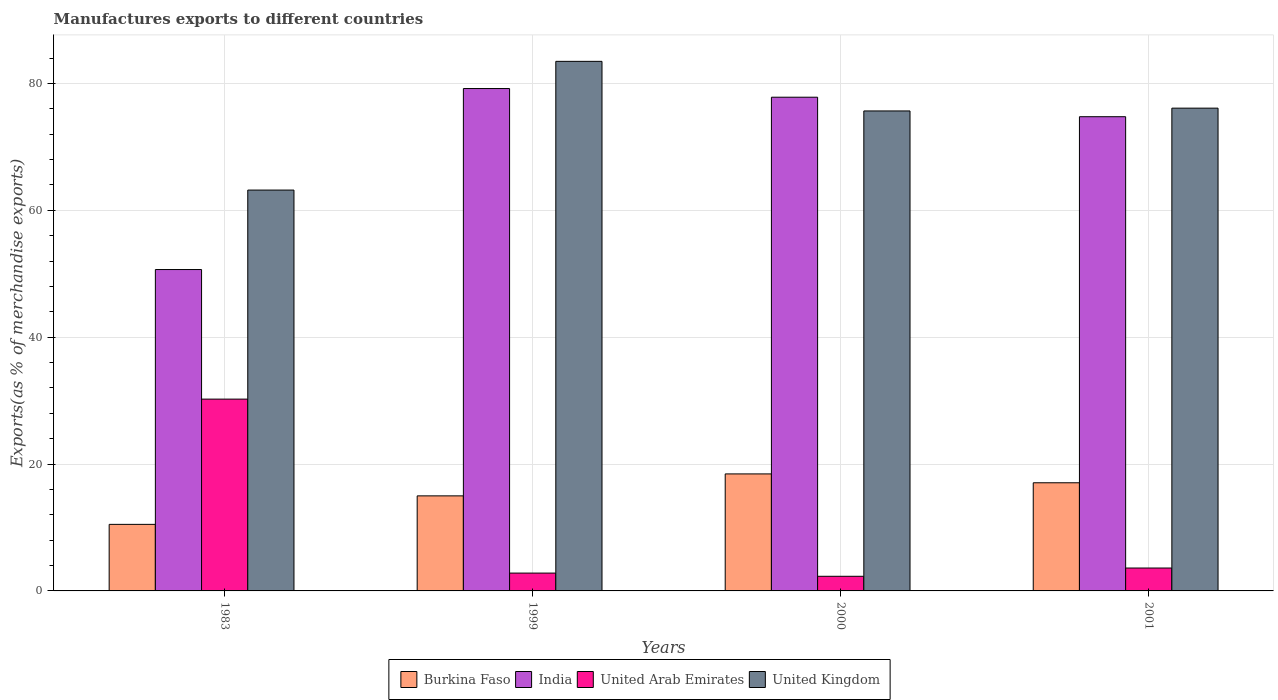How many different coloured bars are there?
Your response must be concise. 4. Are the number of bars on each tick of the X-axis equal?
Keep it short and to the point. Yes. How many bars are there on the 4th tick from the right?
Offer a terse response. 4. What is the label of the 1st group of bars from the left?
Offer a very short reply. 1983. What is the percentage of exports to different countries in India in 2001?
Provide a short and direct response. 74.76. Across all years, what is the maximum percentage of exports to different countries in Burkina Faso?
Your answer should be very brief. 18.45. Across all years, what is the minimum percentage of exports to different countries in India?
Provide a succinct answer. 50.67. In which year was the percentage of exports to different countries in United Kingdom maximum?
Provide a succinct answer. 1999. In which year was the percentage of exports to different countries in United Kingdom minimum?
Provide a succinct answer. 1983. What is the total percentage of exports to different countries in Burkina Faso in the graph?
Offer a terse response. 60.98. What is the difference between the percentage of exports to different countries in United Arab Emirates in 1999 and that in 2000?
Keep it short and to the point. 0.51. What is the difference between the percentage of exports to different countries in India in 2001 and the percentage of exports to different countries in United Arab Emirates in 1999?
Offer a terse response. 71.95. What is the average percentage of exports to different countries in Burkina Faso per year?
Make the answer very short. 15.24. In the year 1999, what is the difference between the percentage of exports to different countries in United Arab Emirates and percentage of exports to different countries in India?
Ensure brevity in your answer.  -76.39. In how many years, is the percentage of exports to different countries in India greater than 8 %?
Provide a short and direct response. 4. What is the ratio of the percentage of exports to different countries in India in 1983 to that in 2001?
Ensure brevity in your answer.  0.68. Is the percentage of exports to different countries in United Kingdom in 1999 less than that in 2001?
Offer a terse response. No. Is the difference between the percentage of exports to different countries in United Arab Emirates in 1983 and 2001 greater than the difference between the percentage of exports to different countries in India in 1983 and 2001?
Make the answer very short. Yes. What is the difference between the highest and the second highest percentage of exports to different countries in United Arab Emirates?
Offer a terse response. 26.63. What is the difference between the highest and the lowest percentage of exports to different countries in United Arab Emirates?
Your answer should be very brief. 27.93. Is it the case that in every year, the sum of the percentage of exports to different countries in India and percentage of exports to different countries in United Arab Emirates is greater than the sum of percentage of exports to different countries in United Kingdom and percentage of exports to different countries in Burkina Faso?
Offer a terse response. No. Is it the case that in every year, the sum of the percentage of exports to different countries in Burkina Faso and percentage of exports to different countries in United Kingdom is greater than the percentage of exports to different countries in India?
Give a very brief answer. Yes. How many bars are there?
Provide a short and direct response. 16. Are all the bars in the graph horizontal?
Provide a short and direct response. No. How many years are there in the graph?
Your response must be concise. 4. Does the graph contain any zero values?
Your response must be concise. No. Does the graph contain grids?
Keep it short and to the point. Yes. How many legend labels are there?
Offer a very short reply. 4. How are the legend labels stacked?
Provide a short and direct response. Horizontal. What is the title of the graph?
Your response must be concise. Manufactures exports to different countries. Does "Turks and Caicos Islands" appear as one of the legend labels in the graph?
Your response must be concise. No. What is the label or title of the Y-axis?
Offer a terse response. Exports(as % of merchandise exports). What is the Exports(as % of merchandise exports) of Burkina Faso in 1983?
Give a very brief answer. 10.49. What is the Exports(as % of merchandise exports) of India in 1983?
Your answer should be very brief. 50.67. What is the Exports(as % of merchandise exports) in United Arab Emirates in 1983?
Your response must be concise. 30.24. What is the Exports(as % of merchandise exports) in United Kingdom in 1983?
Make the answer very short. 63.2. What is the Exports(as % of merchandise exports) of Burkina Faso in 1999?
Keep it short and to the point. 14.98. What is the Exports(as % of merchandise exports) in India in 1999?
Ensure brevity in your answer.  79.2. What is the Exports(as % of merchandise exports) of United Arab Emirates in 1999?
Provide a short and direct response. 2.81. What is the Exports(as % of merchandise exports) in United Kingdom in 1999?
Your response must be concise. 83.49. What is the Exports(as % of merchandise exports) of Burkina Faso in 2000?
Give a very brief answer. 18.45. What is the Exports(as % of merchandise exports) of India in 2000?
Your answer should be compact. 77.84. What is the Exports(as % of merchandise exports) of United Arab Emirates in 2000?
Provide a short and direct response. 2.31. What is the Exports(as % of merchandise exports) in United Kingdom in 2000?
Your answer should be compact. 75.67. What is the Exports(as % of merchandise exports) in Burkina Faso in 2001?
Ensure brevity in your answer.  17.05. What is the Exports(as % of merchandise exports) of India in 2001?
Ensure brevity in your answer.  74.76. What is the Exports(as % of merchandise exports) of United Arab Emirates in 2001?
Keep it short and to the point. 3.61. What is the Exports(as % of merchandise exports) in United Kingdom in 2001?
Provide a succinct answer. 76.11. Across all years, what is the maximum Exports(as % of merchandise exports) of Burkina Faso?
Your answer should be very brief. 18.45. Across all years, what is the maximum Exports(as % of merchandise exports) of India?
Keep it short and to the point. 79.2. Across all years, what is the maximum Exports(as % of merchandise exports) in United Arab Emirates?
Ensure brevity in your answer.  30.24. Across all years, what is the maximum Exports(as % of merchandise exports) of United Kingdom?
Your response must be concise. 83.49. Across all years, what is the minimum Exports(as % of merchandise exports) of Burkina Faso?
Provide a succinct answer. 10.49. Across all years, what is the minimum Exports(as % of merchandise exports) in India?
Keep it short and to the point. 50.67. Across all years, what is the minimum Exports(as % of merchandise exports) of United Arab Emirates?
Provide a succinct answer. 2.31. Across all years, what is the minimum Exports(as % of merchandise exports) in United Kingdom?
Provide a succinct answer. 63.2. What is the total Exports(as % of merchandise exports) of Burkina Faso in the graph?
Offer a very short reply. 60.98. What is the total Exports(as % of merchandise exports) of India in the graph?
Make the answer very short. 282.47. What is the total Exports(as % of merchandise exports) in United Arab Emirates in the graph?
Your answer should be compact. 38.97. What is the total Exports(as % of merchandise exports) of United Kingdom in the graph?
Provide a short and direct response. 298.47. What is the difference between the Exports(as % of merchandise exports) in Burkina Faso in 1983 and that in 1999?
Provide a short and direct response. -4.49. What is the difference between the Exports(as % of merchandise exports) in India in 1983 and that in 1999?
Keep it short and to the point. -28.53. What is the difference between the Exports(as % of merchandise exports) in United Arab Emirates in 1983 and that in 1999?
Offer a terse response. 27.43. What is the difference between the Exports(as % of merchandise exports) of United Kingdom in 1983 and that in 1999?
Your answer should be very brief. -20.29. What is the difference between the Exports(as % of merchandise exports) of Burkina Faso in 1983 and that in 2000?
Your answer should be compact. -7.96. What is the difference between the Exports(as % of merchandise exports) in India in 1983 and that in 2000?
Your answer should be very brief. -27.17. What is the difference between the Exports(as % of merchandise exports) in United Arab Emirates in 1983 and that in 2000?
Your answer should be very brief. 27.93. What is the difference between the Exports(as % of merchandise exports) of United Kingdom in 1983 and that in 2000?
Ensure brevity in your answer.  -12.47. What is the difference between the Exports(as % of merchandise exports) of Burkina Faso in 1983 and that in 2001?
Make the answer very short. -6.56. What is the difference between the Exports(as % of merchandise exports) in India in 1983 and that in 2001?
Offer a terse response. -24.09. What is the difference between the Exports(as % of merchandise exports) in United Arab Emirates in 1983 and that in 2001?
Offer a terse response. 26.63. What is the difference between the Exports(as % of merchandise exports) in United Kingdom in 1983 and that in 2001?
Provide a succinct answer. -12.91. What is the difference between the Exports(as % of merchandise exports) in Burkina Faso in 1999 and that in 2000?
Offer a terse response. -3.46. What is the difference between the Exports(as % of merchandise exports) in India in 1999 and that in 2000?
Your response must be concise. 1.37. What is the difference between the Exports(as % of merchandise exports) in United Arab Emirates in 1999 and that in 2000?
Ensure brevity in your answer.  0.51. What is the difference between the Exports(as % of merchandise exports) in United Kingdom in 1999 and that in 2000?
Make the answer very short. 7.82. What is the difference between the Exports(as % of merchandise exports) in Burkina Faso in 1999 and that in 2001?
Your answer should be compact. -2.07. What is the difference between the Exports(as % of merchandise exports) of India in 1999 and that in 2001?
Your answer should be very brief. 4.44. What is the difference between the Exports(as % of merchandise exports) of United Arab Emirates in 1999 and that in 2001?
Offer a very short reply. -0.8. What is the difference between the Exports(as % of merchandise exports) of United Kingdom in 1999 and that in 2001?
Your answer should be compact. 7.38. What is the difference between the Exports(as % of merchandise exports) of Burkina Faso in 2000 and that in 2001?
Your answer should be compact. 1.4. What is the difference between the Exports(as % of merchandise exports) of India in 2000 and that in 2001?
Offer a very short reply. 3.08. What is the difference between the Exports(as % of merchandise exports) of United Arab Emirates in 2000 and that in 2001?
Provide a short and direct response. -1.3. What is the difference between the Exports(as % of merchandise exports) in United Kingdom in 2000 and that in 2001?
Make the answer very short. -0.44. What is the difference between the Exports(as % of merchandise exports) of Burkina Faso in 1983 and the Exports(as % of merchandise exports) of India in 1999?
Offer a very short reply. -68.71. What is the difference between the Exports(as % of merchandise exports) in Burkina Faso in 1983 and the Exports(as % of merchandise exports) in United Arab Emirates in 1999?
Your answer should be compact. 7.68. What is the difference between the Exports(as % of merchandise exports) in Burkina Faso in 1983 and the Exports(as % of merchandise exports) in United Kingdom in 1999?
Keep it short and to the point. -73. What is the difference between the Exports(as % of merchandise exports) in India in 1983 and the Exports(as % of merchandise exports) in United Arab Emirates in 1999?
Offer a terse response. 47.86. What is the difference between the Exports(as % of merchandise exports) of India in 1983 and the Exports(as % of merchandise exports) of United Kingdom in 1999?
Make the answer very short. -32.82. What is the difference between the Exports(as % of merchandise exports) of United Arab Emirates in 1983 and the Exports(as % of merchandise exports) of United Kingdom in 1999?
Provide a succinct answer. -53.25. What is the difference between the Exports(as % of merchandise exports) of Burkina Faso in 1983 and the Exports(as % of merchandise exports) of India in 2000?
Provide a succinct answer. -67.35. What is the difference between the Exports(as % of merchandise exports) in Burkina Faso in 1983 and the Exports(as % of merchandise exports) in United Arab Emirates in 2000?
Make the answer very short. 8.19. What is the difference between the Exports(as % of merchandise exports) in Burkina Faso in 1983 and the Exports(as % of merchandise exports) in United Kingdom in 2000?
Ensure brevity in your answer.  -65.18. What is the difference between the Exports(as % of merchandise exports) of India in 1983 and the Exports(as % of merchandise exports) of United Arab Emirates in 2000?
Offer a very short reply. 48.36. What is the difference between the Exports(as % of merchandise exports) in India in 1983 and the Exports(as % of merchandise exports) in United Kingdom in 2000?
Your answer should be very brief. -25. What is the difference between the Exports(as % of merchandise exports) of United Arab Emirates in 1983 and the Exports(as % of merchandise exports) of United Kingdom in 2000?
Ensure brevity in your answer.  -45.43. What is the difference between the Exports(as % of merchandise exports) in Burkina Faso in 1983 and the Exports(as % of merchandise exports) in India in 2001?
Make the answer very short. -64.27. What is the difference between the Exports(as % of merchandise exports) in Burkina Faso in 1983 and the Exports(as % of merchandise exports) in United Arab Emirates in 2001?
Offer a very short reply. 6.88. What is the difference between the Exports(as % of merchandise exports) of Burkina Faso in 1983 and the Exports(as % of merchandise exports) of United Kingdom in 2001?
Offer a very short reply. -65.62. What is the difference between the Exports(as % of merchandise exports) of India in 1983 and the Exports(as % of merchandise exports) of United Arab Emirates in 2001?
Your response must be concise. 47.06. What is the difference between the Exports(as % of merchandise exports) of India in 1983 and the Exports(as % of merchandise exports) of United Kingdom in 2001?
Offer a very short reply. -25.44. What is the difference between the Exports(as % of merchandise exports) in United Arab Emirates in 1983 and the Exports(as % of merchandise exports) in United Kingdom in 2001?
Provide a short and direct response. -45.87. What is the difference between the Exports(as % of merchandise exports) of Burkina Faso in 1999 and the Exports(as % of merchandise exports) of India in 2000?
Keep it short and to the point. -62.85. What is the difference between the Exports(as % of merchandise exports) of Burkina Faso in 1999 and the Exports(as % of merchandise exports) of United Arab Emirates in 2000?
Your answer should be compact. 12.68. What is the difference between the Exports(as % of merchandise exports) of Burkina Faso in 1999 and the Exports(as % of merchandise exports) of United Kingdom in 2000?
Keep it short and to the point. -60.69. What is the difference between the Exports(as % of merchandise exports) of India in 1999 and the Exports(as % of merchandise exports) of United Arab Emirates in 2000?
Provide a short and direct response. 76.9. What is the difference between the Exports(as % of merchandise exports) of India in 1999 and the Exports(as % of merchandise exports) of United Kingdom in 2000?
Ensure brevity in your answer.  3.53. What is the difference between the Exports(as % of merchandise exports) of United Arab Emirates in 1999 and the Exports(as % of merchandise exports) of United Kingdom in 2000?
Give a very brief answer. -72.86. What is the difference between the Exports(as % of merchandise exports) of Burkina Faso in 1999 and the Exports(as % of merchandise exports) of India in 2001?
Your answer should be very brief. -59.78. What is the difference between the Exports(as % of merchandise exports) of Burkina Faso in 1999 and the Exports(as % of merchandise exports) of United Arab Emirates in 2001?
Make the answer very short. 11.37. What is the difference between the Exports(as % of merchandise exports) in Burkina Faso in 1999 and the Exports(as % of merchandise exports) in United Kingdom in 2001?
Offer a very short reply. -61.13. What is the difference between the Exports(as % of merchandise exports) in India in 1999 and the Exports(as % of merchandise exports) in United Arab Emirates in 2001?
Give a very brief answer. 75.59. What is the difference between the Exports(as % of merchandise exports) in India in 1999 and the Exports(as % of merchandise exports) in United Kingdom in 2001?
Make the answer very short. 3.09. What is the difference between the Exports(as % of merchandise exports) of United Arab Emirates in 1999 and the Exports(as % of merchandise exports) of United Kingdom in 2001?
Your answer should be compact. -73.3. What is the difference between the Exports(as % of merchandise exports) in Burkina Faso in 2000 and the Exports(as % of merchandise exports) in India in 2001?
Offer a very short reply. -56.31. What is the difference between the Exports(as % of merchandise exports) of Burkina Faso in 2000 and the Exports(as % of merchandise exports) of United Arab Emirates in 2001?
Offer a very short reply. 14.84. What is the difference between the Exports(as % of merchandise exports) of Burkina Faso in 2000 and the Exports(as % of merchandise exports) of United Kingdom in 2001?
Your answer should be compact. -57.66. What is the difference between the Exports(as % of merchandise exports) in India in 2000 and the Exports(as % of merchandise exports) in United Arab Emirates in 2001?
Your answer should be very brief. 74.23. What is the difference between the Exports(as % of merchandise exports) of India in 2000 and the Exports(as % of merchandise exports) of United Kingdom in 2001?
Provide a short and direct response. 1.73. What is the difference between the Exports(as % of merchandise exports) in United Arab Emirates in 2000 and the Exports(as % of merchandise exports) in United Kingdom in 2001?
Offer a terse response. -73.8. What is the average Exports(as % of merchandise exports) in Burkina Faso per year?
Make the answer very short. 15.24. What is the average Exports(as % of merchandise exports) in India per year?
Keep it short and to the point. 70.62. What is the average Exports(as % of merchandise exports) of United Arab Emirates per year?
Keep it short and to the point. 9.74. What is the average Exports(as % of merchandise exports) of United Kingdom per year?
Keep it short and to the point. 74.62. In the year 1983, what is the difference between the Exports(as % of merchandise exports) of Burkina Faso and Exports(as % of merchandise exports) of India?
Provide a short and direct response. -40.18. In the year 1983, what is the difference between the Exports(as % of merchandise exports) of Burkina Faso and Exports(as % of merchandise exports) of United Arab Emirates?
Give a very brief answer. -19.75. In the year 1983, what is the difference between the Exports(as % of merchandise exports) of Burkina Faso and Exports(as % of merchandise exports) of United Kingdom?
Offer a very short reply. -52.7. In the year 1983, what is the difference between the Exports(as % of merchandise exports) in India and Exports(as % of merchandise exports) in United Arab Emirates?
Offer a terse response. 20.43. In the year 1983, what is the difference between the Exports(as % of merchandise exports) in India and Exports(as % of merchandise exports) in United Kingdom?
Offer a very short reply. -12.53. In the year 1983, what is the difference between the Exports(as % of merchandise exports) of United Arab Emirates and Exports(as % of merchandise exports) of United Kingdom?
Your answer should be very brief. -32.96. In the year 1999, what is the difference between the Exports(as % of merchandise exports) of Burkina Faso and Exports(as % of merchandise exports) of India?
Offer a terse response. -64.22. In the year 1999, what is the difference between the Exports(as % of merchandise exports) of Burkina Faso and Exports(as % of merchandise exports) of United Arab Emirates?
Keep it short and to the point. 12.17. In the year 1999, what is the difference between the Exports(as % of merchandise exports) of Burkina Faso and Exports(as % of merchandise exports) of United Kingdom?
Offer a very short reply. -68.5. In the year 1999, what is the difference between the Exports(as % of merchandise exports) of India and Exports(as % of merchandise exports) of United Arab Emirates?
Offer a very short reply. 76.39. In the year 1999, what is the difference between the Exports(as % of merchandise exports) of India and Exports(as % of merchandise exports) of United Kingdom?
Your answer should be compact. -4.29. In the year 1999, what is the difference between the Exports(as % of merchandise exports) in United Arab Emirates and Exports(as % of merchandise exports) in United Kingdom?
Your answer should be very brief. -80.68. In the year 2000, what is the difference between the Exports(as % of merchandise exports) in Burkina Faso and Exports(as % of merchandise exports) in India?
Your answer should be compact. -59.39. In the year 2000, what is the difference between the Exports(as % of merchandise exports) in Burkina Faso and Exports(as % of merchandise exports) in United Arab Emirates?
Offer a very short reply. 16.14. In the year 2000, what is the difference between the Exports(as % of merchandise exports) of Burkina Faso and Exports(as % of merchandise exports) of United Kingdom?
Keep it short and to the point. -57.22. In the year 2000, what is the difference between the Exports(as % of merchandise exports) in India and Exports(as % of merchandise exports) in United Arab Emirates?
Your answer should be very brief. 75.53. In the year 2000, what is the difference between the Exports(as % of merchandise exports) in India and Exports(as % of merchandise exports) in United Kingdom?
Offer a very short reply. 2.17. In the year 2000, what is the difference between the Exports(as % of merchandise exports) of United Arab Emirates and Exports(as % of merchandise exports) of United Kingdom?
Give a very brief answer. -73.36. In the year 2001, what is the difference between the Exports(as % of merchandise exports) of Burkina Faso and Exports(as % of merchandise exports) of India?
Make the answer very short. -57.71. In the year 2001, what is the difference between the Exports(as % of merchandise exports) in Burkina Faso and Exports(as % of merchandise exports) in United Arab Emirates?
Your response must be concise. 13.44. In the year 2001, what is the difference between the Exports(as % of merchandise exports) of Burkina Faso and Exports(as % of merchandise exports) of United Kingdom?
Make the answer very short. -59.06. In the year 2001, what is the difference between the Exports(as % of merchandise exports) in India and Exports(as % of merchandise exports) in United Arab Emirates?
Give a very brief answer. 71.15. In the year 2001, what is the difference between the Exports(as % of merchandise exports) in India and Exports(as % of merchandise exports) in United Kingdom?
Your response must be concise. -1.35. In the year 2001, what is the difference between the Exports(as % of merchandise exports) in United Arab Emirates and Exports(as % of merchandise exports) in United Kingdom?
Your response must be concise. -72.5. What is the ratio of the Exports(as % of merchandise exports) in Burkina Faso in 1983 to that in 1999?
Keep it short and to the point. 0.7. What is the ratio of the Exports(as % of merchandise exports) in India in 1983 to that in 1999?
Offer a terse response. 0.64. What is the ratio of the Exports(as % of merchandise exports) in United Arab Emirates in 1983 to that in 1999?
Provide a short and direct response. 10.75. What is the ratio of the Exports(as % of merchandise exports) in United Kingdom in 1983 to that in 1999?
Ensure brevity in your answer.  0.76. What is the ratio of the Exports(as % of merchandise exports) in Burkina Faso in 1983 to that in 2000?
Your response must be concise. 0.57. What is the ratio of the Exports(as % of merchandise exports) of India in 1983 to that in 2000?
Keep it short and to the point. 0.65. What is the ratio of the Exports(as % of merchandise exports) of United Arab Emirates in 1983 to that in 2000?
Offer a terse response. 13.11. What is the ratio of the Exports(as % of merchandise exports) in United Kingdom in 1983 to that in 2000?
Make the answer very short. 0.84. What is the ratio of the Exports(as % of merchandise exports) in Burkina Faso in 1983 to that in 2001?
Keep it short and to the point. 0.62. What is the ratio of the Exports(as % of merchandise exports) of India in 1983 to that in 2001?
Provide a succinct answer. 0.68. What is the ratio of the Exports(as % of merchandise exports) in United Arab Emirates in 1983 to that in 2001?
Make the answer very short. 8.37. What is the ratio of the Exports(as % of merchandise exports) of United Kingdom in 1983 to that in 2001?
Offer a terse response. 0.83. What is the ratio of the Exports(as % of merchandise exports) in Burkina Faso in 1999 to that in 2000?
Provide a succinct answer. 0.81. What is the ratio of the Exports(as % of merchandise exports) in India in 1999 to that in 2000?
Provide a short and direct response. 1.02. What is the ratio of the Exports(as % of merchandise exports) of United Arab Emirates in 1999 to that in 2000?
Make the answer very short. 1.22. What is the ratio of the Exports(as % of merchandise exports) in United Kingdom in 1999 to that in 2000?
Make the answer very short. 1.1. What is the ratio of the Exports(as % of merchandise exports) in Burkina Faso in 1999 to that in 2001?
Make the answer very short. 0.88. What is the ratio of the Exports(as % of merchandise exports) in India in 1999 to that in 2001?
Your answer should be very brief. 1.06. What is the ratio of the Exports(as % of merchandise exports) of United Arab Emirates in 1999 to that in 2001?
Give a very brief answer. 0.78. What is the ratio of the Exports(as % of merchandise exports) in United Kingdom in 1999 to that in 2001?
Offer a very short reply. 1.1. What is the ratio of the Exports(as % of merchandise exports) in Burkina Faso in 2000 to that in 2001?
Your answer should be compact. 1.08. What is the ratio of the Exports(as % of merchandise exports) in India in 2000 to that in 2001?
Provide a succinct answer. 1.04. What is the ratio of the Exports(as % of merchandise exports) in United Arab Emirates in 2000 to that in 2001?
Offer a terse response. 0.64. What is the difference between the highest and the second highest Exports(as % of merchandise exports) of Burkina Faso?
Your answer should be very brief. 1.4. What is the difference between the highest and the second highest Exports(as % of merchandise exports) in India?
Provide a short and direct response. 1.37. What is the difference between the highest and the second highest Exports(as % of merchandise exports) of United Arab Emirates?
Offer a very short reply. 26.63. What is the difference between the highest and the second highest Exports(as % of merchandise exports) of United Kingdom?
Offer a terse response. 7.38. What is the difference between the highest and the lowest Exports(as % of merchandise exports) in Burkina Faso?
Your response must be concise. 7.96. What is the difference between the highest and the lowest Exports(as % of merchandise exports) of India?
Give a very brief answer. 28.53. What is the difference between the highest and the lowest Exports(as % of merchandise exports) of United Arab Emirates?
Offer a very short reply. 27.93. What is the difference between the highest and the lowest Exports(as % of merchandise exports) in United Kingdom?
Your answer should be very brief. 20.29. 